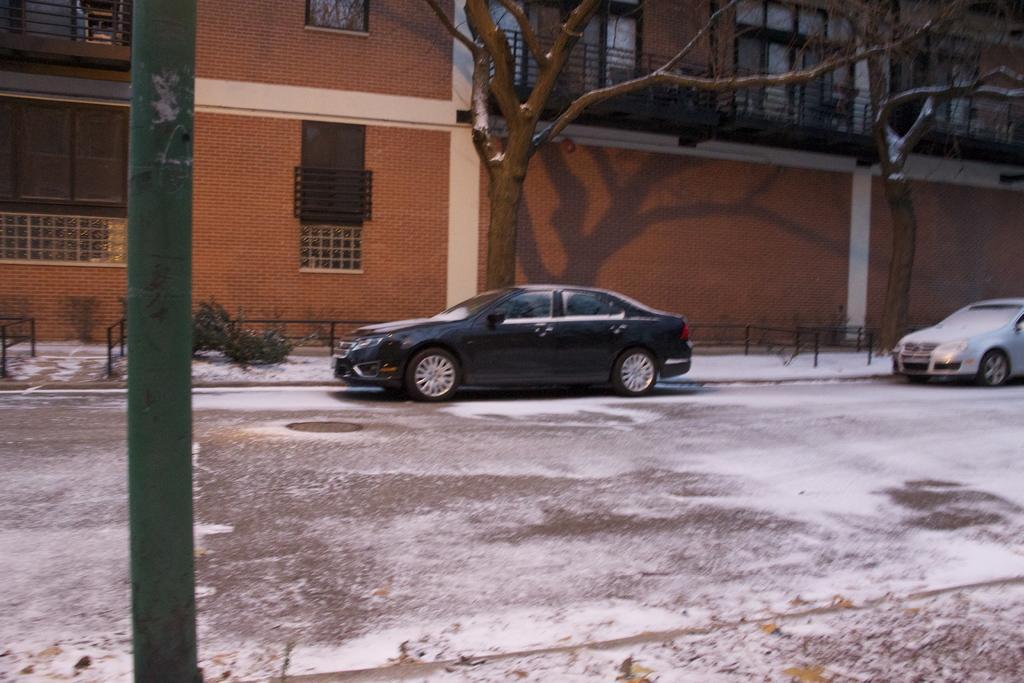How would you summarize this image in a sentence or two? In this picture we can see cars on the road, pole, trees and in the background we can see a building with windows. 